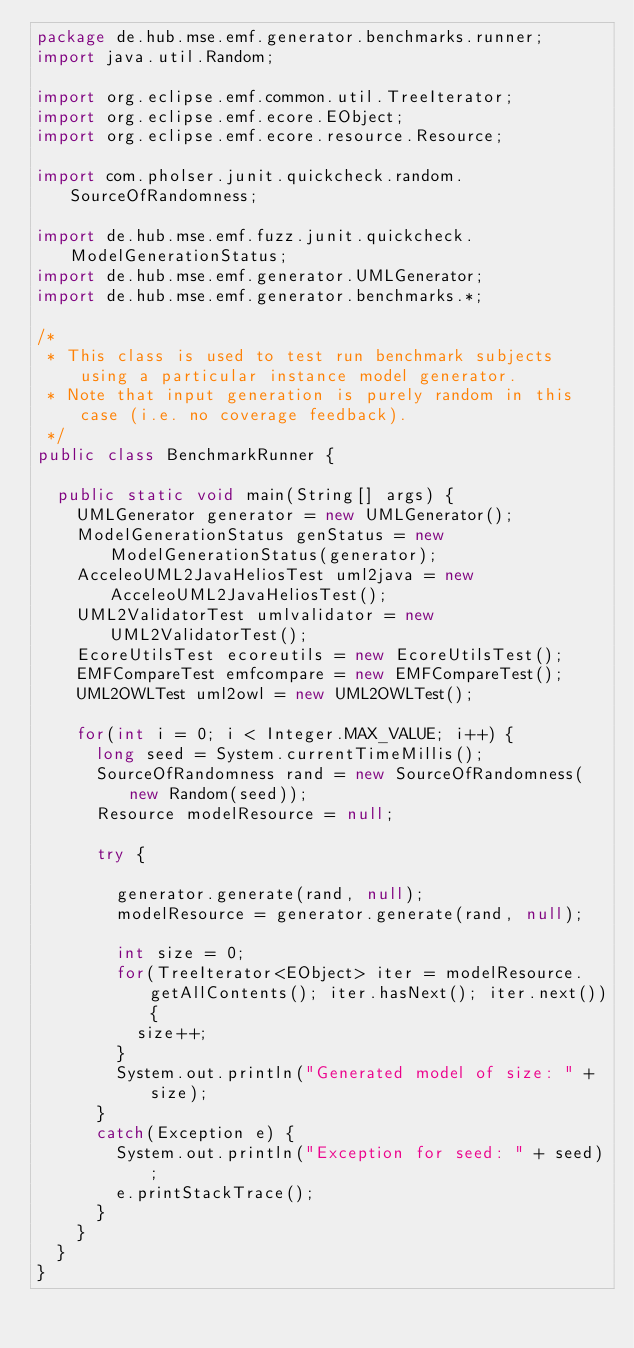Convert code to text. <code><loc_0><loc_0><loc_500><loc_500><_Java_>package de.hub.mse.emf.generator.benchmarks.runner;
import java.util.Random;

import org.eclipse.emf.common.util.TreeIterator;
import org.eclipse.emf.ecore.EObject;
import org.eclipse.emf.ecore.resource.Resource;

import com.pholser.junit.quickcheck.random.SourceOfRandomness;

import de.hub.mse.emf.fuzz.junit.quickcheck.ModelGenerationStatus;
import de.hub.mse.emf.generator.UMLGenerator;
import de.hub.mse.emf.generator.benchmarks.*;

/*
 * This class is used to test run benchmark subjects using a particular instance model generator.
 * Note that input generation is purely random in this case (i.e. no coverage feedback).
 */
public class BenchmarkRunner {

	public static void main(String[] args) {
		UMLGenerator generator = new UMLGenerator();
		ModelGenerationStatus genStatus = new ModelGenerationStatus(generator);
		AcceleoUML2JavaHeliosTest uml2java = new AcceleoUML2JavaHeliosTest();
		UML2ValidatorTest umlvalidator = new UML2ValidatorTest();
		EcoreUtilsTest ecoreutils = new EcoreUtilsTest();
		EMFCompareTest emfcompare = new EMFCompareTest();
		UML2OWLTest uml2owl = new UML2OWLTest();
		
		for(int i = 0; i < Integer.MAX_VALUE; i++) {
			long seed = System.currentTimeMillis();					
			SourceOfRandomness rand = new SourceOfRandomness(new Random(seed));
			Resource modelResource = null;
			
			try {
					
				generator.generate(rand, null);
				modelResource = generator.generate(rand, null);
				
				int size = 0;
				for(TreeIterator<EObject> iter = modelResource.getAllContents(); iter.hasNext(); iter.next()){
					size++;
				}
				System.out.println("Generated model of size: " + size);
			}
			catch(Exception e) {
				System.out.println("Exception for seed: " + seed);
				e.printStackTrace();
			}
		}
	}
}
</code> 